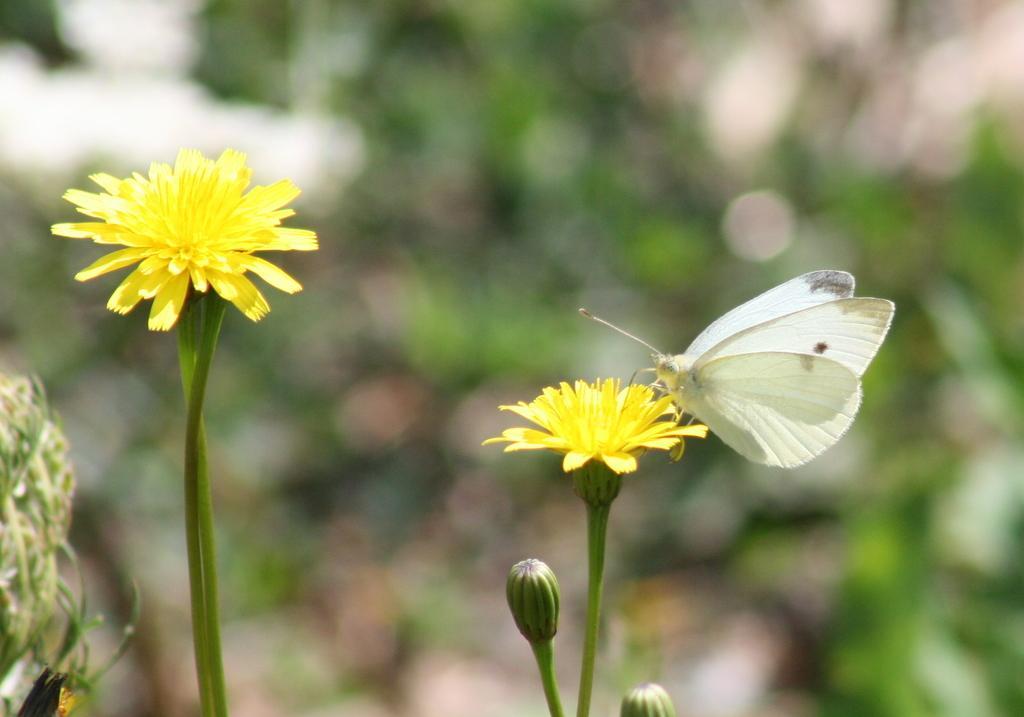Please provide a concise description of this image. In this picture I can see 2 yellow color flowers and 2 buds and on the right flower, I can see a white color butterfly on it and I see that it is totally blurred in the background. 